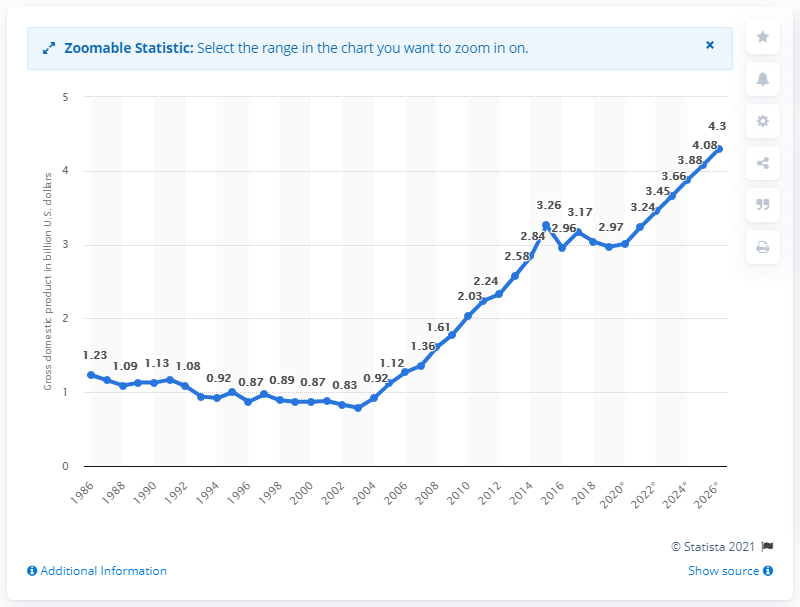Specify some key components in this picture. According to the data, Burundi's Gross Domestic Product in 2019 was 2.97. 